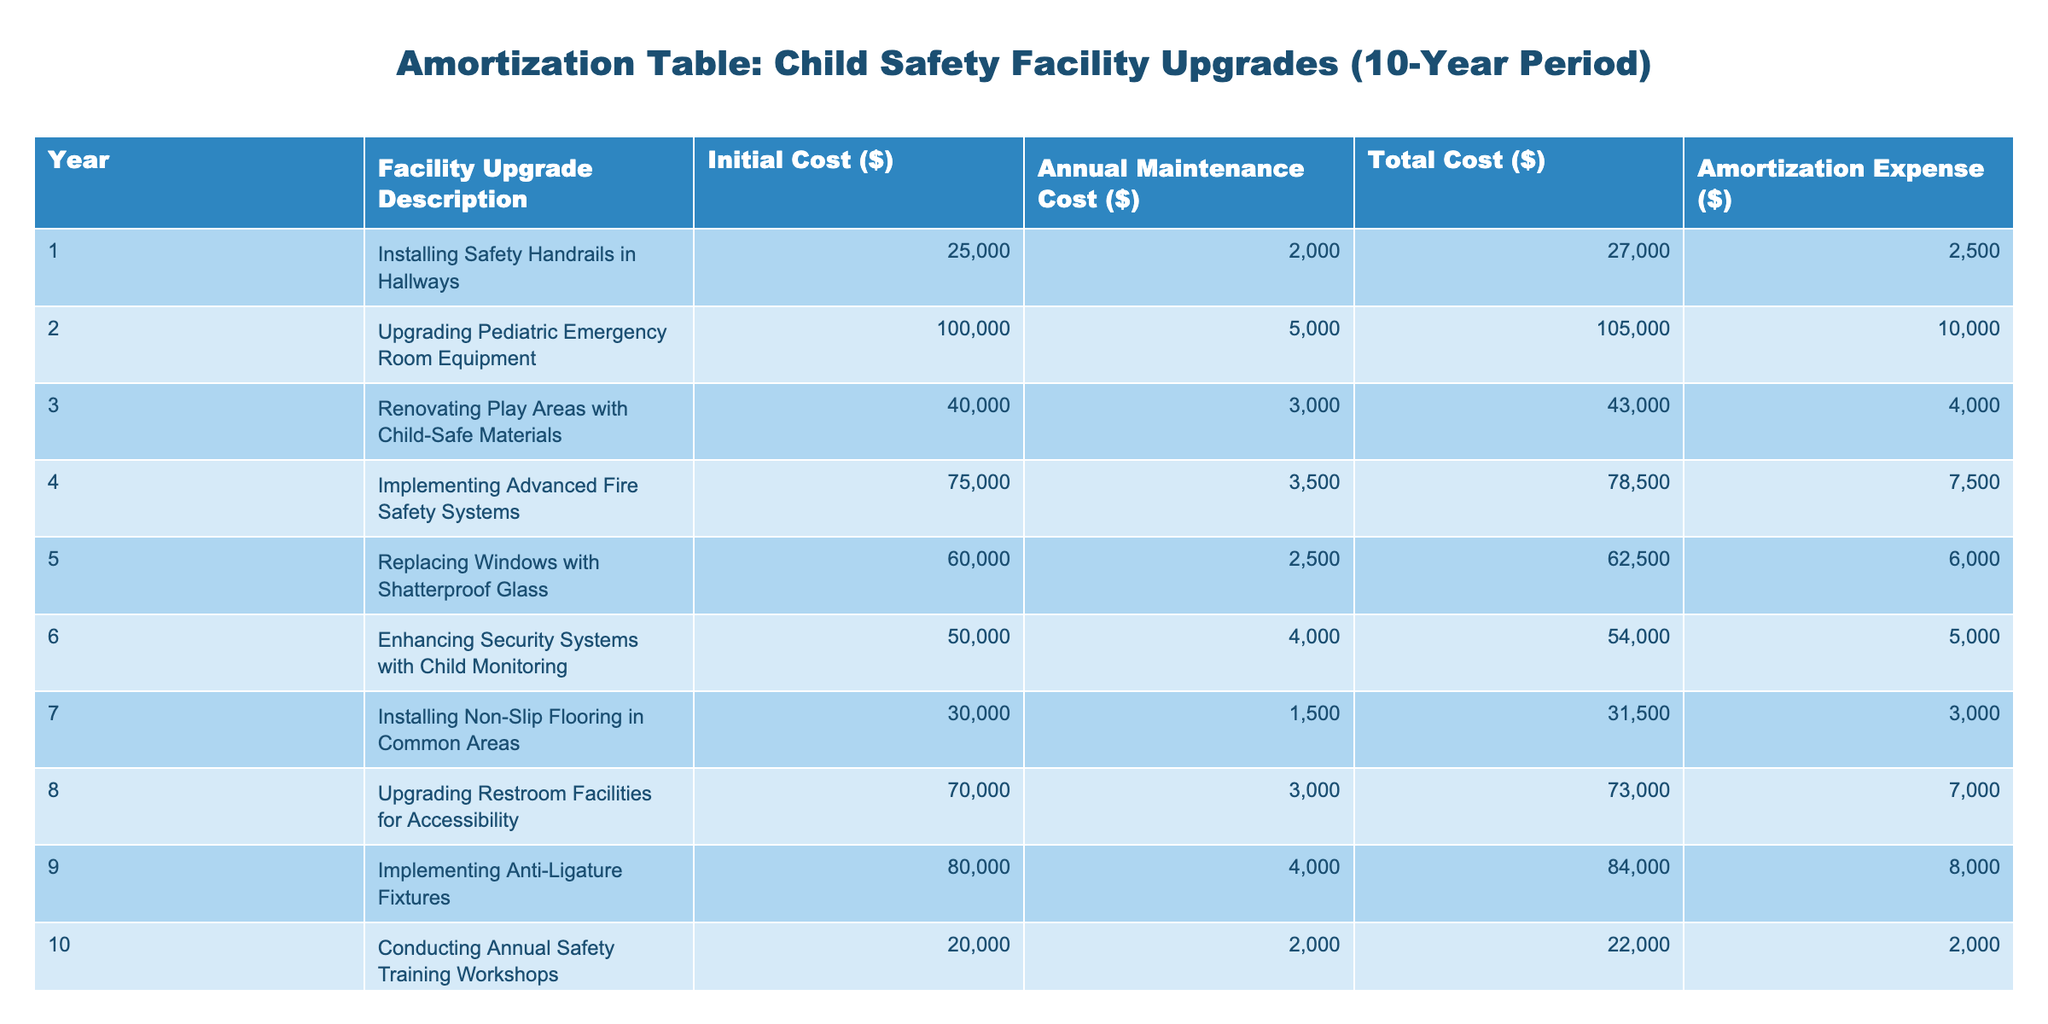What was the initial cost of upgrading the Pediatric Emergency Room Equipment? The table shows that for Year 2, the Facility Upgrade Description is "Upgrading Pediatric Emergency Room Equipment," which lists the Initial Cost as $100,000.
Answer: $100,000 How much is the total cost for installing Safety Handrails in Hallways? Referring to Year 1, the Total Cost for "Installing Safety Handrails in Hallways" is $27,000.
Answer: $27,000 Which facility upgrade has the highest annual maintenance cost? Comparing the Annual Maintenance Costs across all upgrades, the "Upgrading Pediatric Emergency Room Equipment" has the highest annual maintenance cost of $5,000.
Answer: $5,000 What is the average amortization expense for all facility upgrades? Summing all the Amortization Expenses: (2,500 + 10,000 + 4,000 + 7,500 + 6,000 + 5,000 + 3,000 + 7,000 + 8,000 + 2,000 = 53,000), then dividing by 10 gives an average of 5,300.
Answer: $5,300 Is the total cost for enhancing security systems with child monitoring lower than the total cost for conducting annual safety training workshops? The Total Cost for enhancing security systems is $54,000 and for conducting workshops is $22,000. Since $54,000 is greater than $22,000, the statement is false.
Answer: No What is the total cost of the upgrades that include safety elements, such as handrails and non-slip flooring? The total cost for "Installing Safety Handrails in Hallways" is $27,000 and for "Installing Non-Slip Flooring in Common Areas" is $31,500. Adding these gives $27,000 + $31,500 = $58,500.
Answer: $58,500 Which year had the highest initial cost for a facility upgrade? Year 2 had the highest initial cost, which is $100,000 for "Upgrading Pediatric Emergency Room Equipment." No other year exceeds this amount.
Answer: Year 2 How much more was spent on renovating play areas than on replacing windows with shatterproof glass? The Total Cost for renovating play areas is $43,000 and for replacing windows is $62,500. The difference is $62,500 - $43,000 = $19,500, indicating that more was spent on the windows upgrade.
Answer: $19,500 